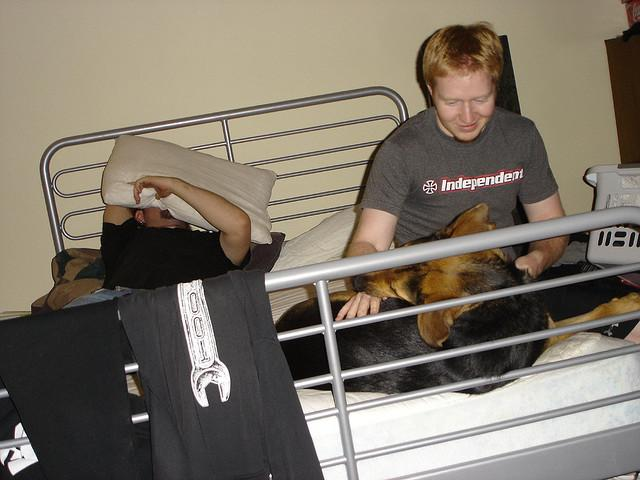What tool is printed on the shirt on the railing?

Choices:
A) hammer
B) chisel
C) screwdriver
D) wrench wrench 